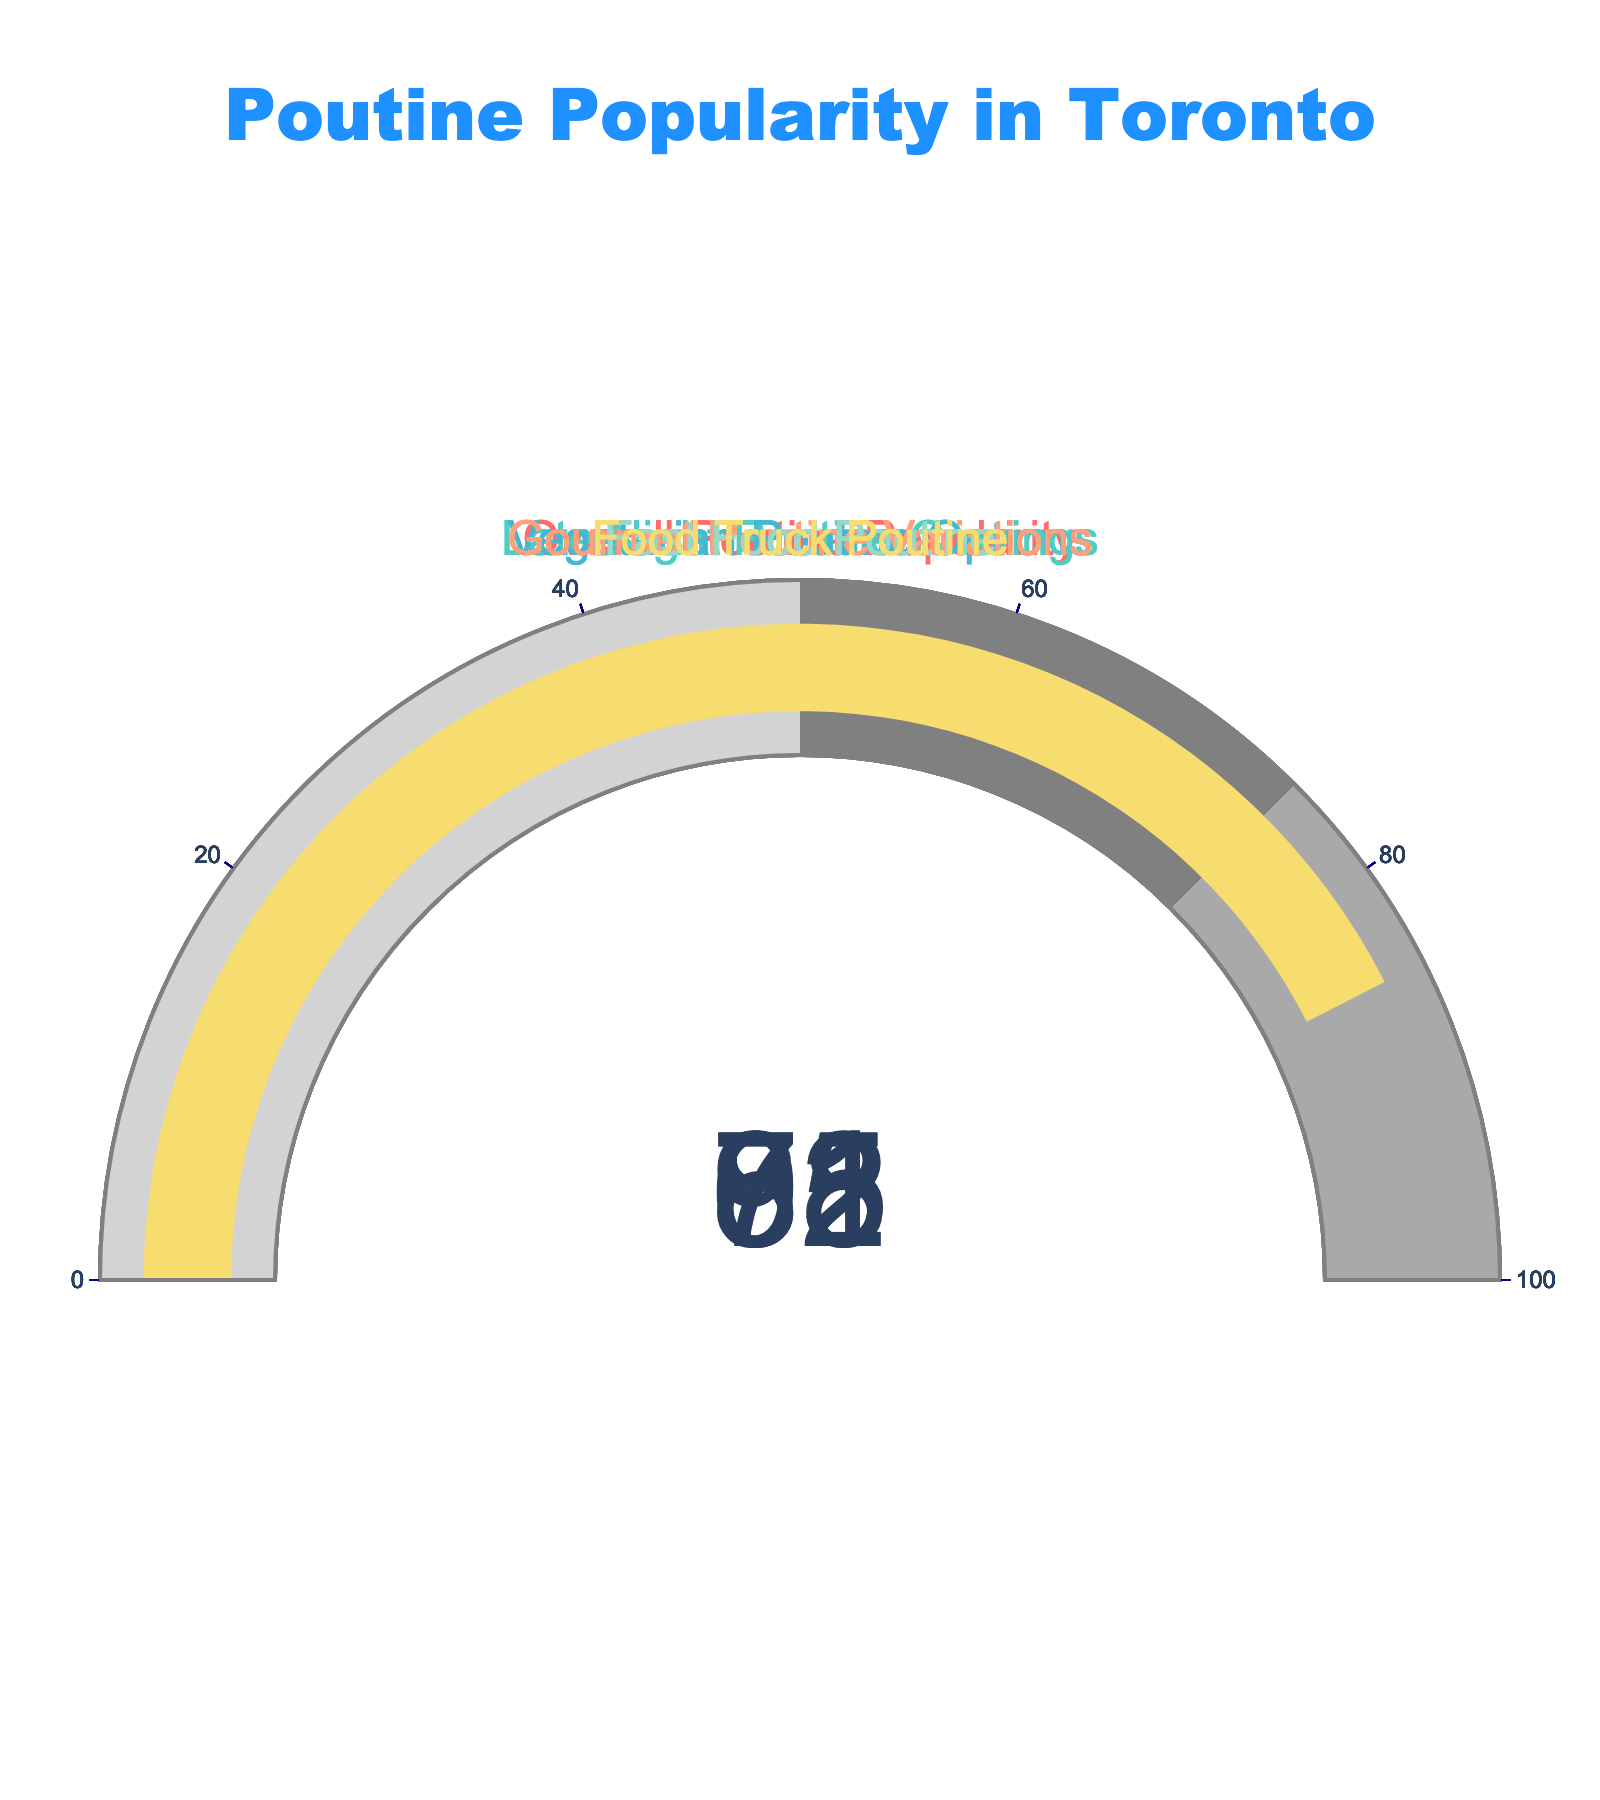What's the overall popularity rating of poutine among Toronto residents? The gauge for the "Overall Poutine Popularity" shows a rating of 78.
Answer: 78 How popular are late night poutine cravings in Toronto? The gauge titled "Late Night Poutine Cravings" shows a rating of 92.
Answer: 92 Which poutine category has the lowest popularity rating? By observing the gauge charts, "Vegetarian Poutine Options" has the lowest rating of 65.
Answer: Vegetarian Poutine Options What is the difference in popularity between gourmet poutine variations and fast food poutine? The rating for "Gourmet Poutine Variations" is 81, and for "Fast Food Poutine" it is 71. The difference is 81 - 71 = 10.
Answer: 10 Which type of poutine has the highest popularity rating in Toronto? The gauge chart with the highest rating is "Late Night Poutine Cravings" with a rating of 92.
Answer: Late Night Poutine Cravings What is the average rating of all poutine categories displayed? The ratings are 78, 92, 65, 81, 71, 85. The sum is 78 + 92 + 65 + 81 + 71 + 85 = 472. The number of categories is 6, so the average rating is 472 / 6 = 78.67.
Answer: 78.67 How much more popular are food truck poutine options compared to vegetarian poutine options? The rating for "Food Truck Poutine" is 85 and for "Vegetarian Poutine Options" it is 65. The difference is 85 - 65 = 20.
Answer: 20 What is the median value of the ratings for the poutine categories? The ratings are 78, 92, 65, 81, 71, 85. When ordered: 65, 71, 78, 81, 85, 92. The middle values are 78 and 81. The median is (78 + 81) / 2 = 79.5.
Answer: 79.5 